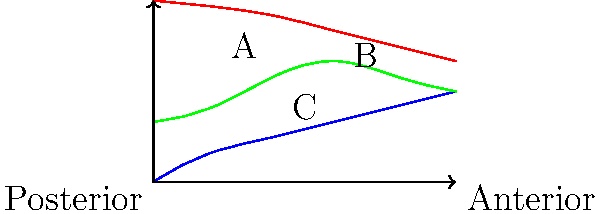In the cross-sectional diagram of the vocal tract, three main resonance chambers are labeled A, B, and C. Which chamber is primarily responsible for producing the "singer's formant," a concentration of acoustic energy around 3000 Hz that helps singers project their voice over an orchestra? To answer this question, let's analyze the diagram and the resonance chambers:

1. Chamber A: This is the largest cavity, located in the upper part of the vocal tract. It represents the pharyngeal cavity or pharynx.

2. Chamber B: This is a smaller cavity above the tongue, representing the oral cavity or mouth.

3. Chamber C: This is the smallest cavity, located between the tongue and the throat, representing the laryngeal cavity or larynx tube.

The "singer's formant" is a phenomenon crucial for voice projection, especially for singers with hearing impairments who may rely more on physical sensations. To understand which chamber is responsible for this:

1. The singer's formant is produced by clustering the third, fourth, and fifth formants close together.

2. This clustering occurs due to a specific ratio between the volume of the larynx tube and the pharynx.

3. The larynx tube (Chamber C) acts as a separate resonator when it's sufficiently wide relative to the pharynx.

4. When the larynx is lowered, it lengthens and widens the larynx tube, creating the ideal conditions for the singer's formant.

5. The increased width of the larynx tube causes it to resonate at a frequency close to the third, fourth, and fifth formants, clustering them together.

Therefore, the laryngeal cavity (Chamber C) is primarily responsible for producing the singer's formant.
Answer: Chamber C (laryngeal cavity) 